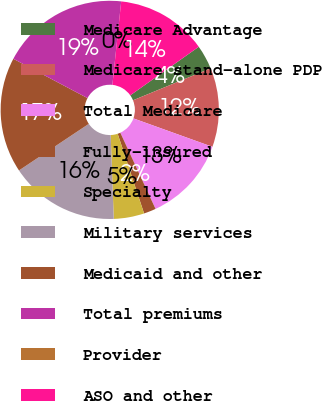Convert chart to OTSL. <chart><loc_0><loc_0><loc_500><loc_500><pie_chart><fcel>Medicare Advantage<fcel>Medicare stand-alone PDP<fcel>Total Medicare<fcel>Fully-insured<fcel>Specialty<fcel>Military services<fcel>Medicaid and other<fcel>Total premiums<fcel>Provider<fcel>ASO and other<nl><fcel>3.6%<fcel>11.71%<fcel>12.61%<fcel>1.8%<fcel>4.51%<fcel>16.22%<fcel>17.12%<fcel>18.92%<fcel>0.0%<fcel>13.51%<nl></chart> 